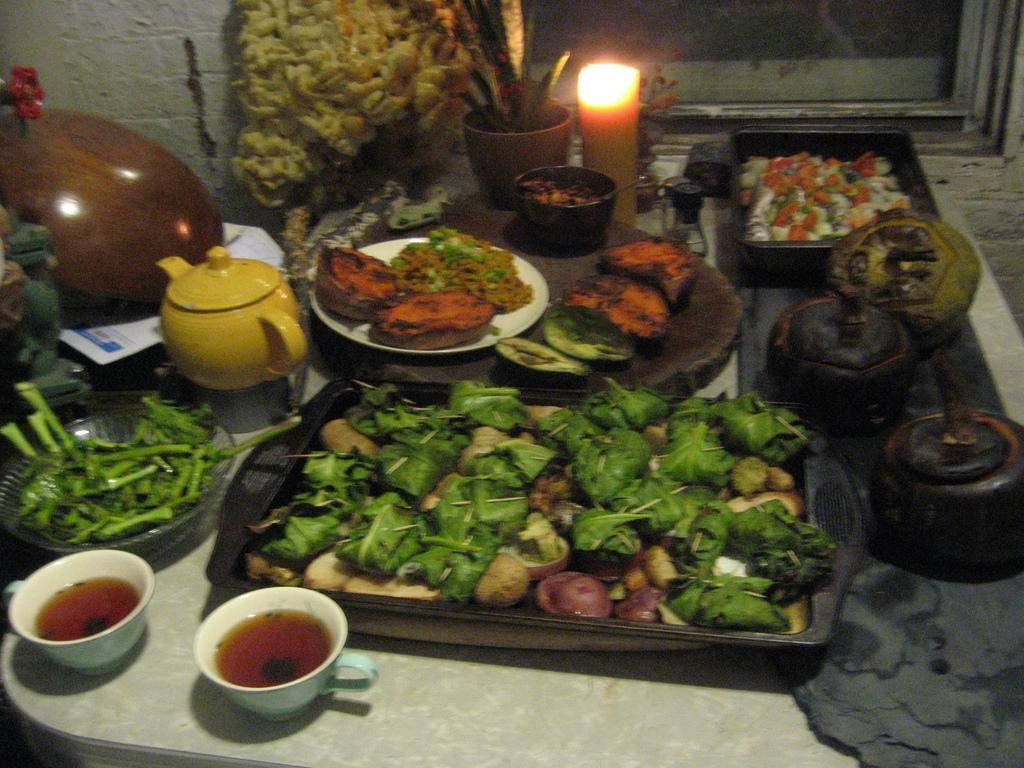What type of dishware is present in the image? There are bowls, trays, and a plate in the image. What other items can be seen in the image? There is a candle and a plant in the image. What might be served on the dishware in the image? There are food items in the image. Where is the property located in the image? There is no property present in the image. Can you see a door in the image? There is no door present in the image. Is there a tent visible in the image? There is no tent present in the image. 